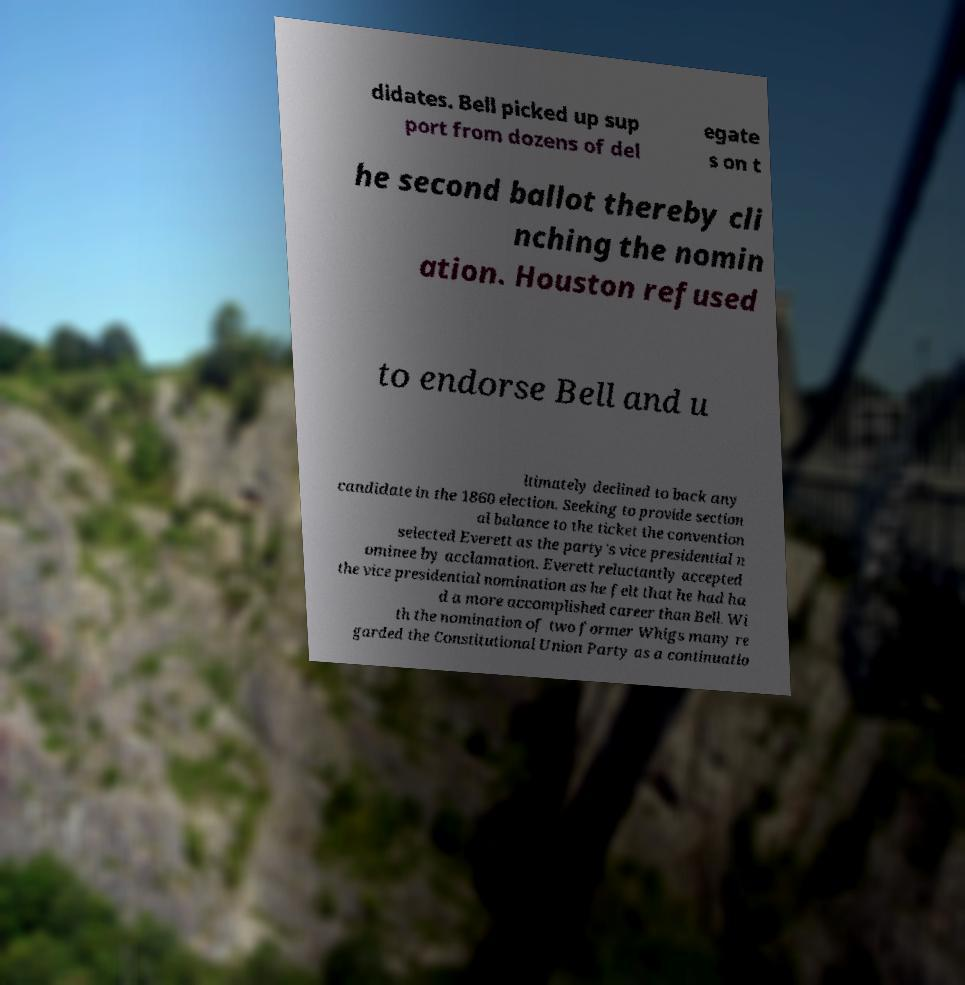Can you accurately transcribe the text from the provided image for me? didates. Bell picked up sup port from dozens of del egate s on t he second ballot thereby cli nching the nomin ation. Houston refused to endorse Bell and u ltimately declined to back any candidate in the 1860 election. Seeking to provide section al balance to the ticket the convention selected Everett as the party's vice presidential n ominee by acclamation. Everett reluctantly accepted the vice presidential nomination as he felt that he had ha d a more accomplished career than Bell. Wi th the nomination of two former Whigs many re garded the Constitutional Union Party as a continuatio 